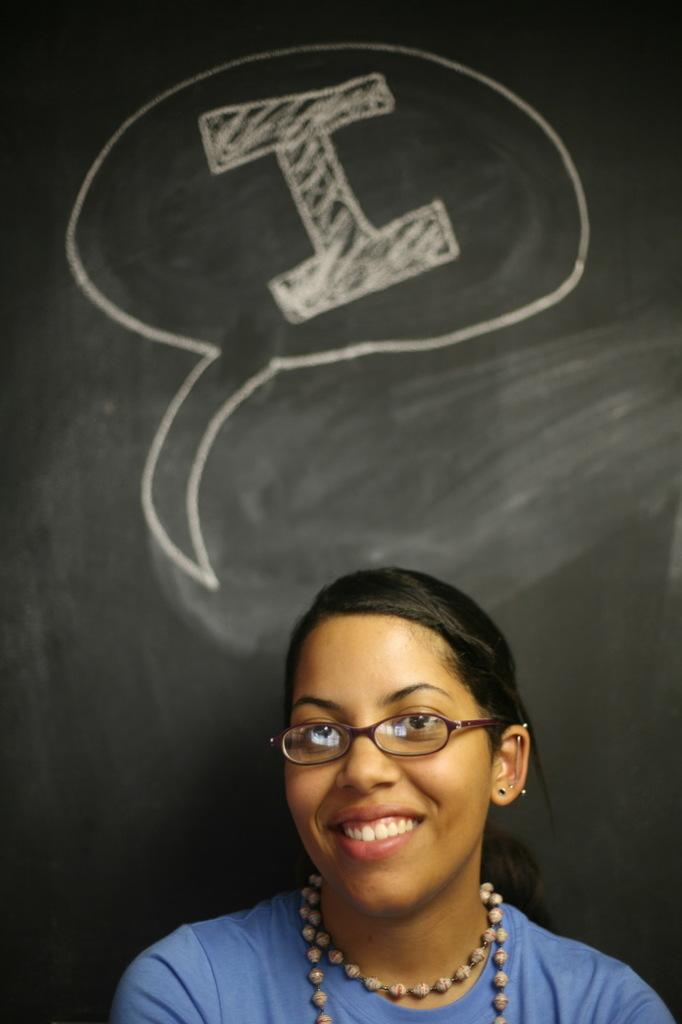Who is present in the image? There is a woman in the image. What is the woman's expression? The woman is smiling. What accessory is the woman wearing? The woman is wearing spectacles. What can be seen in the background of the image? There is a blackboard in the background of the image. What is written on the blackboard? Something is written on the blackboard. What type of hose is being advertised on the form in the image? There is no hose or form present in the image; it features a woman smiling and wearing spectacles, with a blackboard in the background. 